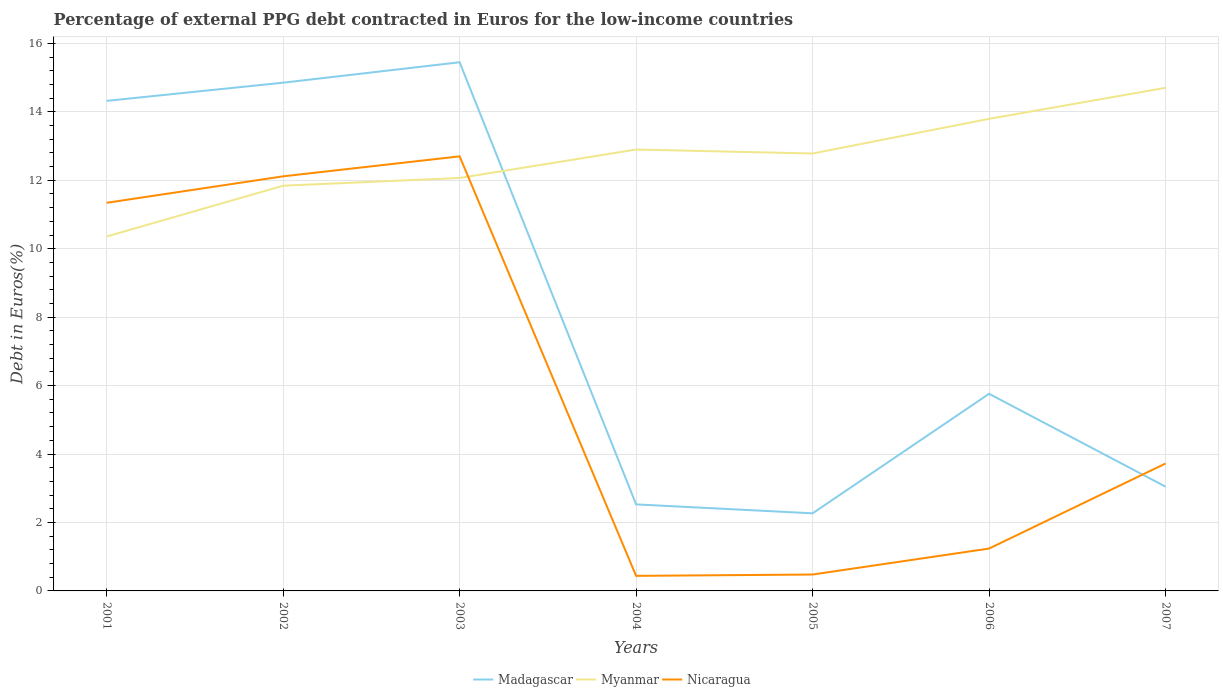Does the line corresponding to Madagascar intersect with the line corresponding to Nicaragua?
Offer a very short reply. Yes. Is the number of lines equal to the number of legend labels?
Your answer should be compact. Yes. Across all years, what is the maximum percentage of external PPG debt contracted in Euros in Myanmar?
Your response must be concise. 10.36. In which year was the percentage of external PPG debt contracted in Euros in Nicaragua maximum?
Your answer should be very brief. 2004. What is the total percentage of external PPG debt contracted in Euros in Nicaragua in the graph?
Keep it short and to the point. -2.49. What is the difference between the highest and the second highest percentage of external PPG debt contracted in Euros in Myanmar?
Ensure brevity in your answer.  4.35. What is the difference between two consecutive major ticks on the Y-axis?
Provide a short and direct response. 2. Are the values on the major ticks of Y-axis written in scientific E-notation?
Your response must be concise. No. Does the graph contain any zero values?
Your response must be concise. No. How many legend labels are there?
Offer a terse response. 3. How are the legend labels stacked?
Your response must be concise. Horizontal. What is the title of the graph?
Give a very brief answer. Percentage of external PPG debt contracted in Euros for the low-income countries. What is the label or title of the Y-axis?
Offer a very short reply. Debt in Euros(%). What is the Debt in Euros(%) in Madagascar in 2001?
Ensure brevity in your answer.  14.32. What is the Debt in Euros(%) of Myanmar in 2001?
Your response must be concise. 10.36. What is the Debt in Euros(%) of Nicaragua in 2001?
Your answer should be compact. 11.34. What is the Debt in Euros(%) in Madagascar in 2002?
Your answer should be very brief. 14.85. What is the Debt in Euros(%) of Myanmar in 2002?
Keep it short and to the point. 11.84. What is the Debt in Euros(%) in Nicaragua in 2002?
Your response must be concise. 12.12. What is the Debt in Euros(%) of Madagascar in 2003?
Keep it short and to the point. 15.45. What is the Debt in Euros(%) of Myanmar in 2003?
Provide a short and direct response. 12.07. What is the Debt in Euros(%) in Nicaragua in 2003?
Provide a succinct answer. 12.7. What is the Debt in Euros(%) in Madagascar in 2004?
Provide a succinct answer. 2.53. What is the Debt in Euros(%) of Myanmar in 2004?
Your answer should be compact. 12.9. What is the Debt in Euros(%) in Nicaragua in 2004?
Provide a succinct answer. 0.44. What is the Debt in Euros(%) of Madagascar in 2005?
Your answer should be very brief. 2.27. What is the Debt in Euros(%) in Myanmar in 2005?
Provide a short and direct response. 12.78. What is the Debt in Euros(%) of Nicaragua in 2005?
Your answer should be compact. 0.48. What is the Debt in Euros(%) in Madagascar in 2006?
Provide a short and direct response. 5.76. What is the Debt in Euros(%) of Myanmar in 2006?
Make the answer very short. 13.8. What is the Debt in Euros(%) of Nicaragua in 2006?
Offer a terse response. 1.24. What is the Debt in Euros(%) in Madagascar in 2007?
Give a very brief answer. 3.05. What is the Debt in Euros(%) in Myanmar in 2007?
Make the answer very short. 14.7. What is the Debt in Euros(%) in Nicaragua in 2007?
Keep it short and to the point. 3.72. Across all years, what is the maximum Debt in Euros(%) of Madagascar?
Offer a terse response. 15.45. Across all years, what is the maximum Debt in Euros(%) in Myanmar?
Offer a very short reply. 14.7. Across all years, what is the maximum Debt in Euros(%) in Nicaragua?
Give a very brief answer. 12.7. Across all years, what is the minimum Debt in Euros(%) in Madagascar?
Ensure brevity in your answer.  2.27. Across all years, what is the minimum Debt in Euros(%) of Myanmar?
Ensure brevity in your answer.  10.36. Across all years, what is the minimum Debt in Euros(%) in Nicaragua?
Ensure brevity in your answer.  0.44. What is the total Debt in Euros(%) of Madagascar in the graph?
Your answer should be very brief. 58.23. What is the total Debt in Euros(%) in Myanmar in the graph?
Your answer should be very brief. 88.45. What is the total Debt in Euros(%) of Nicaragua in the graph?
Your response must be concise. 42.04. What is the difference between the Debt in Euros(%) in Madagascar in 2001 and that in 2002?
Give a very brief answer. -0.53. What is the difference between the Debt in Euros(%) in Myanmar in 2001 and that in 2002?
Make the answer very short. -1.48. What is the difference between the Debt in Euros(%) of Nicaragua in 2001 and that in 2002?
Provide a succinct answer. -0.77. What is the difference between the Debt in Euros(%) of Madagascar in 2001 and that in 2003?
Offer a terse response. -1.13. What is the difference between the Debt in Euros(%) of Myanmar in 2001 and that in 2003?
Make the answer very short. -1.71. What is the difference between the Debt in Euros(%) in Nicaragua in 2001 and that in 2003?
Your answer should be very brief. -1.36. What is the difference between the Debt in Euros(%) of Madagascar in 2001 and that in 2004?
Give a very brief answer. 11.79. What is the difference between the Debt in Euros(%) in Myanmar in 2001 and that in 2004?
Your response must be concise. -2.54. What is the difference between the Debt in Euros(%) in Nicaragua in 2001 and that in 2004?
Offer a terse response. 10.9. What is the difference between the Debt in Euros(%) in Madagascar in 2001 and that in 2005?
Offer a terse response. 12.05. What is the difference between the Debt in Euros(%) in Myanmar in 2001 and that in 2005?
Your response must be concise. -2.43. What is the difference between the Debt in Euros(%) of Nicaragua in 2001 and that in 2005?
Offer a very short reply. 10.86. What is the difference between the Debt in Euros(%) of Madagascar in 2001 and that in 2006?
Offer a terse response. 8.56. What is the difference between the Debt in Euros(%) of Myanmar in 2001 and that in 2006?
Ensure brevity in your answer.  -3.44. What is the difference between the Debt in Euros(%) in Nicaragua in 2001 and that in 2006?
Your answer should be very brief. 10.1. What is the difference between the Debt in Euros(%) of Madagascar in 2001 and that in 2007?
Your answer should be compact. 11.27. What is the difference between the Debt in Euros(%) of Myanmar in 2001 and that in 2007?
Ensure brevity in your answer.  -4.35. What is the difference between the Debt in Euros(%) in Nicaragua in 2001 and that in 2007?
Offer a very short reply. 7.62. What is the difference between the Debt in Euros(%) in Madagascar in 2002 and that in 2003?
Give a very brief answer. -0.6. What is the difference between the Debt in Euros(%) of Myanmar in 2002 and that in 2003?
Your answer should be very brief. -0.23. What is the difference between the Debt in Euros(%) in Nicaragua in 2002 and that in 2003?
Give a very brief answer. -0.58. What is the difference between the Debt in Euros(%) of Madagascar in 2002 and that in 2004?
Give a very brief answer. 12.32. What is the difference between the Debt in Euros(%) in Myanmar in 2002 and that in 2004?
Make the answer very short. -1.06. What is the difference between the Debt in Euros(%) in Nicaragua in 2002 and that in 2004?
Ensure brevity in your answer.  11.68. What is the difference between the Debt in Euros(%) in Madagascar in 2002 and that in 2005?
Your answer should be compact. 12.58. What is the difference between the Debt in Euros(%) of Myanmar in 2002 and that in 2005?
Provide a succinct answer. -0.94. What is the difference between the Debt in Euros(%) in Nicaragua in 2002 and that in 2005?
Offer a terse response. 11.64. What is the difference between the Debt in Euros(%) in Madagascar in 2002 and that in 2006?
Your answer should be very brief. 9.09. What is the difference between the Debt in Euros(%) of Myanmar in 2002 and that in 2006?
Ensure brevity in your answer.  -1.95. What is the difference between the Debt in Euros(%) in Nicaragua in 2002 and that in 2006?
Provide a short and direct response. 10.88. What is the difference between the Debt in Euros(%) in Madagascar in 2002 and that in 2007?
Offer a terse response. 11.81. What is the difference between the Debt in Euros(%) in Myanmar in 2002 and that in 2007?
Your response must be concise. -2.86. What is the difference between the Debt in Euros(%) of Nicaragua in 2002 and that in 2007?
Provide a short and direct response. 8.39. What is the difference between the Debt in Euros(%) of Madagascar in 2003 and that in 2004?
Your answer should be compact. 12.92. What is the difference between the Debt in Euros(%) in Myanmar in 2003 and that in 2004?
Make the answer very short. -0.83. What is the difference between the Debt in Euros(%) of Nicaragua in 2003 and that in 2004?
Your answer should be very brief. 12.26. What is the difference between the Debt in Euros(%) of Madagascar in 2003 and that in 2005?
Your response must be concise. 13.18. What is the difference between the Debt in Euros(%) of Myanmar in 2003 and that in 2005?
Your answer should be compact. -0.71. What is the difference between the Debt in Euros(%) of Nicaragua in 2003 and that in 2005?
Make the answer very short. 12.22. What is the difference between the Debt in Euros(%) in Madagascar in 2003 and that in 2006?
Offer a terse response. 9.69. What is the difference between the Debt in Euros(%) in Myanmar in 2003 and that in 2006?
Give a very brief answer. -1.73. What is the difference between the Debt in Euros(%) of Nicaragua in 2003 and that in 2006?
Offer a terse response. 11.46. What is the difference between the Debt in Euros(%) of Madagascar in 2003 and that in 2007?
Offer a very short reply. 12.4. What is the difference between the Debt in Euros(%) of Myanmar in 2003 and that in 2007?
Provide a succinct answer. -2.63. What is the difference between the Debt in Euros(%) of Nicaragua in 2003 and that in 2007?
Offer a terse response. 8.98. What is the difference between the Debt in Euros(%) in Madagascar in 2004 and that in 2005?
Ensure brevity in your answer.  0.26. What is the difference between the Debt in Euros(%) of Myanmar in 2004 and that in 2005?
Keep it short and to the point. 0.12. What is the difference between the Debt in Euros(%) of Nicaragua in 2004 and that in 2005?
Make the answer very short. -0.04. What is the difference between the Debt in Euros(%) in Madagascar in 2004 and that in 2006?
Provide a succinct answer. -3.23. What is the difference between the Debt in Euros(%) of Myanmar in 2004 and that in 2006?
Offer a very short reply. -0.9. What is the difference between the Debt in Euros(%) in Nicaragua in 2004 and that in 2006?
Your answer should be compact. -0.8. What is the difference between the Debt in Euros(%) in Madagascar in 2004 and that in 2007?
Offer a terse response. -0.52. What is the difference between the Debt in Euros(%) in Myanmar in 2004 and that in 2007?
Your answer should be very brief. -1.8. What is the difference between the Debt in Euros(%) of Nicaragua in 2004 and that in 2007?
Ensure brevity in your answer.  -3.28. What is the difference between the Debt in Euros(%) of Madagascar in 2005 and that in 2006?
Keep it short and to the point. -3.49. What is the difference between the Debt in Euros(%) of Myanmar in 2005 and that in 2006?
Make the answer very short. -1.01. What is the difference between the Debt in Euros(%) of Nicaragua in 2005 and that in 2006?
Make the answer very short. -0.76. What is the difference between the Debt in Euros(%) of Madagascar in 2005 and that in 2007?
Make the answer very short. -0.78. What is the difference between the Debt in Euros(%) in Myanmar in 2005 and that in 2007?
Your answer should be compact. -1.92. What is the difference between the Debt in Euros(%) of Nicaragua in 2005 and that in 2007?
Provide a succinct answer. -3.24. What is the difference between the Debt in Euros(%) of Madagascar in 2006 and that in 2007?
Provide a succinct answer. 2.71. What is the difference between the Debt in Euros(%) in Myanmar in 2006 and that in 2007?
Give a very brief answer. -0.91. What is the difference between the Debt in Euros(%) in Nicaragua in 2006 and that in 2007?
Offer a terse response. -2.49. What is the difference between the Debt in Euros(%) in Madagascar in 2001 and the Debt in Euros(%) in Myanmar in 2002?
Your answer should be compact. 2.48. What is the difference between the Debt in Euros(%) of Madagascar in 2001 and the Debt in Euros(%) of Nicaragua in 2002?
Keep it short and to the point. 2.21. What is the difference between the Debt in Euros(%) in Myanmar in 2001 and the Debt in Euros(%) in Nicaragua in 2002?
Provide a short and direct response. -1.76. What is the difference between the Debt in Euros(%) of Madagascar in 2001 and the Debt in Euros(%) of Myanmar in 2003?
Provide a short and direct response. 2.25. What is the difference between the Debt in Euros(%) in Madagascar in 2001 and the Debt in Euros(%) in Nicaragua in 2003?
Provide a short and direct response. 1.62. What is the difference between the Debt in Euros(%) in Myanmar in 2001 and the Debt in Euros(%) in Nicaragua in 2003?
Provide a succinct answer. -2.34. What is the difference between the Debt in Euros(%) of Madagascar in 2001 and the Debt in Euros(%) of Myanmar in 2004?
Offer a very short reply. 1.42. What is the difference between the Debt in Euros(%) in Madagascar in 2001 and the Debt in Euros(%) in Nicaragua in 2004?
Your answer should be compact. 13.88. What is the difference between the Debt in Euros(%) in Myanmar in 2001 and the Debt in Euros(%) in Nicaragua in 2004?
Ensure brevity in your answer.  9.92. What is the difference between the Debt in Euros(%) in Madagascar in 2001 and the Debt in Euros(%) in Myanmar in 2005?
Your response must be concise. 1.54. What is the difference between the Debt in Euros(%) in Madagascar in 2001 and the Debt in Euros(%) in Nicaragua in 2005?
Your answer should be very brief. 13.84. What is the difference between the Debt in Euros(%) in Myanmar in 2001 and the Debt in Euros(%) in Nicaragua in 2005?
Provide a succinct answer. 9.88. What is the difference between the Debt in Euros(%) in Madagascar in 2001 and the Debt in Euros(%) in Myanmar in 2006?
Your response must be concise. 0.53. What is the difference between the Debt in Euros(%) of Madagascar in 2001 and the Debt in Euros(%) of Nicaragua in 2006?
Provide a short and direct response. 13.08. What is the difference between the Debt in Euros(%) of Myanmar in 2001 and the Debt in Euros(%) of Nicaragua in 2006?
Ensure brevity in your answer.  9.12. What is the difference between the Debt in Euros(%) of Madagascar in 2001 and the Debt in Euros(%) of Myanmar in 2007?
Provide a succinct answer. -0.38. What is the difference between the Debt in Euros(%) of Madagascar in 2001 and the Debt in Euros(%) of Nicaragua in 2007?
Your answer should be compact. 10.6. What is the difference between the Debt in Euros(%) of Myanmar in 2001 and the Debt in Euros(%) of Nicaragua in 2007?
Make the answer very short. 6.63. What is the difference between the Debt in Euros(%) of Madagascar in 2002 and the Debt in Euros(%) of Myanmar in 2003?
Make the answer very short. 2.78. What is the difference between the Debt in Euros(%) of Madagascar in 2002 and the Debt in Euros(%) of Nicaragua in 2003?
Keep it short and to the point. 2.15. What is the difference between the Debt in Euros(%) of Myanmar in 2002 and the Debt in Euros(%) of Nicaragua in 2003?
Offer a very short reply. -0.86. What is the difference between the Debt in Euros(%) in Madagascar in 2002 and the Debt in Euros(%) in Myanmar in 2004?
Your answer should be very brief. 1.95. What is the difference between the Debt in Euros(%) in Madagascar in 2002 and the Debt in Euros(%) in Nicaragua in 2004?
Provide a short and direct response. 14.41. What is the difference between the Debt in Euros(%) of Myanmar in 2002 and the Debt in Euros(%) of Nicaragua in 2004?
Provide a succinct answer. 11.4. What is the difference between the Debt in Euros(%) of Madagascar in 2002 and the Debt in Euros(%) of Myanmar in 2005?
Provide a short and direct response. 2.07. What is the difference between the Debt in Euros(%) of Madagascar in 2002 and the Debt in Euros(%) of Nicaragua in 2005?
Offer a terse response. 14.37. What is the difference between the Debt in Euros(%) in Myanmar in 2002 and the Debt in Euros(%) in Nicaragua in 2005?
Your answer should be compact. 11.36. What is the difference between the Debt in Euros(%) of Madagascar in 2002 and the Debt in Euros(%) of Myanmar in 2006?
Make the answer very short. 1.06. What is the difference between the Debt in Euros(%) of Madagascar in 2002 and the Debt in Euros(%) of Nicaragua in 2006?
Ensure brevity in your answer.  13.61. What is the difference between the Debt in Euros(%) of Myanmar in 2002 and the Debt in Euros(%) of Nicaragua in 2006?
Offer a very short reply. 10.6. What is the difference between the Debt in Euros(%) of Madagascar in 2002 and the Debt in Euros(%) of Myanmar in 2007?
Offer a terse response. 0.15. What is the difference between the Debt in Euros(%) in Madagascar in 2002 and the Debt in Euros(%) in Nicaragua in 2007?
Keep it short and to the point. 11.13. What is the difference between the Debt in Euros(%) in Myanmar in 2002 and the Debt in Euros(%) in Nicaragua in 2007?
Make the answer very short. 8.12. What is the difference between the Debt in Euros(%) of Madagascar in 2003 and the Debt in Euros(%) of Myanmar in 2004?
Provide a short and direct response. 2.55. What is the difference between the Debt in Euros(%) of Madagascar in 2003 and the Debt in Euros(%) of Nicaragua in 2004?
Offer a very short reply. 15.01. What is the difference between the Debt in Euros(%) of Myanmar in 2003 and the Debt in Euros(%) of Nicaragua in 2004?
Provide a succinct answer. 11.63. What is the difference between the Debt in Euros(%) of Madagascar in 2003 and the Debt in Euros(%) of Myanmar in 2005?
Ensure brevity in your answer.  2.67. What is the difference between the Debt in Euros(%) in Madagascar in 2003 and the Debt in Euros(%) in Nicaragua in 2005?
Provide a succinct answer. 14.97. What is the difference between the Debt in Euros(%) of Myanmar in 2003 and the Debt in Euros(%) of Nicaragua in 2005?
Offer a terse response. 11.59. What is the difference between the Debt in Euros(%) of Madagascar in 2003 and the Debt in Euros(%) of Myanmar in 2006?
Your response must be concise. 1.65. What is the difference between the Debt in Euros(%) in Madagascar in 2003 and the Debt in Euros(%) in Nicaragua in 2006?
Provide a succinct answer. 14.21. What is the difference between the Debt in Euros(%) of Myanmar in 2003 and the Debt in Euros(%) of Nicaragua in 2006?
Provide a succinct answer. 10.83. What is the difference between the Debt in Euros(%) in Madagascar in 2003 and the Debt in Euros(%) in Myanmar in 2007?
Offer a terse response. 0.75. What is the difference between the Debt in Euros(%) in Madagascar in 2003 and the Debt in Euros(%) in Nicaragua in 2007?
Provide a succinct answer. 11.73. What is the difference between the Debt in Euros(%) in Myanmar in 2003 and the Debt in Euros(%) in Nicaragua in 2007?
Offer a very short reply. 8.34. What is the difference between the Debt in Euros(%) in Madagascar in 2004 and the Debt in Euros(%) in Myanmar in 2005?
Keep it short and to the point. -10.25. What is the difference between the Debt in Euros(%) of Madagascar in 2004 and the Debt in Euros(%) of Nicaragua in 2005?
Your answer should be compact. 2.05. What is the difference between the Debt in Euros(%) in Myanmar in 2004 and the Debt in Euros(%) in Nicaragua in 2005?
Provide a succinct answer. 12.42. What is the difference between the Debt in Euros(%) in Madagascar in 2004 and the Debt in Euros(%) in Myanmar in 2006?
Offer a very short reply. -11.27. What is the difference between the Debt in Euros(%) of Madagascar in 2004 and the Debt in Euros(%) of Nicaragua in 2006?
Give a very brief answer. 1.29. What is the difference between the Debt in Euros(%) in Myanmar in 2004 and the Debt in Euros(%) in Nicaragua in 2006?
Offer a terse response. 11.66. What is the difference between the Debt in Euros(%) of Madagascar in 2004 and the Debt in Euros(%) of Myanmar in 2007?
Give a very brief answer. -12.17. What is the difference between the Debt in Euros(%) in Madagascar in 2004 and the Debt in Euros(%) in Nicaragua in 2007?
Your answer should be very brief. -1.2. What is the difference between the Debt in Euros(%) in Myanmar in 2004 and the Debt in Euros(%) in Nicaragua in 2007?
Give a very brief answer. 9.18. What is the difference between the Debt in Euros(%) of Madagascar in 2005 and the Debt in Euros(%) of Myanmar in 2006?
Provide a succinct answer. -11.53. What is the difference between the Debt in Euros(%) of Madagascar in 2005 and the Debt in Euros(%) of Nicaragua in 2006?
Give a very brief answer. 1.03. What is the difference between the Debt in Euros(%) in Myanmar in 2005 and the Debt in Euros(%) in Nicaragua in 2006?
Offer a very short reply. 11.54. What is the difference between the Debt in Euros(%) of Madagascar in 2005 and the Debt in Euros(%) of Myanmar in 2007?
Keep it short and to the point. -12.43. What is the difference between the Debt in Euros(%) in Madagascar in 2005 and the Debt in Euros(%) in Nicaragua in 2007?
Ensure brevity in your answer.  -1.46. What is the difference between the Debt in Euros(%) of Myanmar in 2005 and the Debt in Euros(%) of Nicaragua in 2007?
Keep it short and to the point. 9.06. What is the difference between the Debt in Euros(%) of Madagascar in 2006 and the Debt in Euros(%) of Myanmar in 2007?
Your answer should be very brief. -8.94. What is the difference between the Debt in Euros(%) in Madagascar in 2006 and the Debt in Euros(%) in Nicaragua in 2007?
Make the answer very short. 2.04. What is the difference between the Debt in Euros(%) of Myanmar in 2006 and the Debt in Euros(%) of Nicaragua in 2007?
Your response must be concise. 10.07. What is the average Debt in Euros(%) of Madagascar per year?
Your response must be concise. 8.32. What is the average Debt in Euros(%) in Myanmar per year?
Give a very brief answer. 12.63. What is the average Debt in Euros(%) in Nicaragua per year?
Offer a terse response. 6.01. In the year 2001, what is the difference between the Debt in Euros(%) of Madagascar and Debt in Euros(%) of Myanmar?
Give a very brief answer. 3.96. In the year 2001, what is the difference between the Debt in Euros(%) of Madagascar and Debt in Euros(%) of Nicaragua?
Provide a succinct answer. 2.98. In the year 2001, what is the difference between the Debt in Euros(%) in Myanmar and Debt in Euros(%) in Nicaragua?
Make the answer very short. -0.99. In the year 2002, what is the difference between the Debt in Euros(%) in Madagascar and Debt in Euros(%) in Myanmar?
Provide a short and direct response. 3.01. In the year 2002, what is the difference between the Debt in Euros(%) in Madagascar and Debt in Euros(%) in Nicaragua?
Offer a terse response. 2.74. In the year 2002, what is the difference between the Debt in Euros(%) of Myanmar and Debt in Euros(%) of Nicaragua?
Give a very brief answer. -0.27. In the year 2003, what is the difference between the Debt in Euros(%) in Madagascar and Debt in Euros(%) in Myanmar?
Provide a succinct answer. 3.38. In the year 2003, what is the difference between the Debt in Euros(%) of Madagascar and Debt in Euros(%) of Nicaragua?
Your response must be concise. 2.75. In the year 2003, what is the difference between the Debt in Euros(%) in Myanmar and Debt in Euros(%) in Nicaragua?
Make the answer very short. -0.63. In the year 2004, what is the difference between the Debt in Euros(%) of Madagascar and Debt in Euros(%) of Myanmar?
Keep it short and to the point. -10.37. In the year 2004, what is the difference between the Debt in Euros(%) of Madagascar and Debt in Euros(%) of Nicaragua?
Give a very brief answer. 2.09. In the year 2004, what is the difference between the Debt in Euros(%) of Myanmar and Debt in Euros(%) of Nicaragua?
Provide a succinct answer. 12.46. In the year 2005, what is the difference between the Debt in Euros(%) in Madagascar and Debt in Euros(%) in Myanmar?
Provide a short and direct response. -10.51. In the year 2005, what is the difference between the Debt in Euros(%) of Madagascar and Debt in Euros(%) of Nicaragua?
Offer a very short reply. 1.79. In the year 2005, what is the difference between the Debt in Euros(%) of Myanmar and Debt in Euros(%) of Nicaragua?
Provide a short and direct response. 12.3. In the year 2006, what is the difference between the Debt in Euros(%) in Madagascar and Debt in Euros(%) in Myanmar?
Make the answer very short. -8.03. In the year 2006, what is the difference between the Debt in Euros(%) in Madagascar and Debt in Euros(%) in Nicaragua?
Your response must be concise. 4.52. In the year 2006, what is the difference between the Debt in Euros(%) of Myanmar and Debt in Euros(%) of Nicaragua?
Offer a very short reply. 12.56. In the year 2007, what is the difference between the Debt in Euros(%) of Madagascar and Debt in Euros(%) of Myanmar?
Provide a succinct answer. -11.66. In the year 2007, what is the difference between the Debt in Euros(%) of Madagascar and Debt in Euros(%) of Nicaragua?
Make the answer very short. -0.68. In the year 2007, what is the difference between the Debt in Euros(%) in Myanmar and Debt in Euros(%) in Nicaragua?
Give a very brief answer. 10.98. What is the ratio of the Debt in Euros(%) of Madagascar in 2001 to that in 2002?
Your answer should be compact. 0.96. What is the ratio of the Debt in Euros(%) of Myanmar in 2001 to that in 2002?
Provide a short and direct response. 0.87. What is the ratio of the Debt in Euros(%) in Nicaragua in 2001 to that in 2002?
Make the answer very short. 0.94. What is the ratio of the Debt in Euros(%) of Madagascar in 2001 to that in 2003?
Your answer should be very brief. 0.93. What is the ratio of the Debt in Euros(%) of Myanmar in 2001 to that in 2003?
Provide a succinct answer. 0.86. What is the ratio of the Debt in Euros(%) in Nicaragua in 2001 to that in 2003?
Your response must be concise. 0.89. What is the ratio of the Debt in Euros(%) in Madagascar in 2001 to that in 2004?
Offer a terse response. 5.66. What is the ratio of the Debt in Euros(%) in Myanmar in 2001 to that in 2004?
Your response must be concise. 0.8. What is the ratio of the Debt in Euros(%) of Nicaragua in 2001 to that in 2004?
Offer a very short reply. 25.77. What is the ratio of the Debt in Euros(%) in Madagascar in 2001 to that in 2005?
Provide a short and direct response. 6.31. What is the ratio of the Debt in Euros(%) in Myanmar in 2001 to that in 2005?
Provide a short and direct response. 0.81. What is the ratio of the Debt in Euros(%) of Nicaragua in 2001 to that in 2005?
Provide a succinct answer. 23.67. What is the ratio of the Debt in Euros(%) of Madagascar in 2001 to that in 2006?
Give a very brief answer. 2.49. What is the ratio of the Debt in Euros(%) in Myanmar in 2001 to that in 2006?
Keep it short and to the point. 0.75. What is the ratio of the Debt in Euros(%) of Nicaragua in 2001 to that in 2006?
Offer a very short reply. 9.16. What is the ratio of the Debt in Euros(%) in Madagascar in 2001 to that in 2007?
Keep it short and to the point. 4.7. What is the ratio of the Debt in Euros(%) in Myanmar in 2001 to that in 2007?
Your answer should be very brief. 0.7. What is the ratio of the Debt in Euros(%) in Nicaragua in 2001 to that in 2007?
Your answer should be very brief. 3.05. What is the ratio of the Debt in Euros(%) in Madagascar in 2002 to that in 2003?
Your answer should be very brief. 0.96. What is the ratio of the Debt in Euros(%) of Myanmar in 2002 to that in 2003?
Keep it short and to the point. 0.98. What is the ratio of the Debt in Euros(%) of Nicaragua in 2002 to that in 2003?
Your answer should be very brief. 0.95. What is the ratio of the Debt in Euros(%) in Madagascar in 2002 to that in 2004?
Ensure brevity in your answer.  5.87. What is the ratio of the Debt in Euros(%) in Myanmar in 2002 to that in 2004?
Your answer should be very brief. 0.92. What is the ratio of the Debt in Euros(%) in Nicaragua in 2002 to that in 2004?
Your answer should be very brief. 27.52. What is the ratio of the Debt in Euros(%) in Madagascar in 2002 to that in 2005?
Provide a succinct answer. 6.55. What is the ratio of the Debt in Euros(%) in Myanmar in 2002 to that in 2005?
Your response must be concise. 0.93. What is the ratio of the Debt in Euros(%) in Nicaragua in 2002 to that in 2005?
Keep it short and to the point. 25.29. What is the ratio of the Debt in Euros(%) in Madagascar in 2002 to that in 2006?
Offer a very short reply. 2.58. What is the ratio of the Debt in Euros(%) of Myanmar in 2002 to that in 2006?
Your response must be concise. 0.86. What is the ratio of the Debt in Euros(%) of Nicaragua in 2002 to that in 2006?
Offer a very short reply. 9.78. What is the ratio of the Debt in Euros(%) of Madagascar in 2002 to that in 2007?
Keep it short and to the point. 4.87. What is the ratio of the Debt in Euros(%) in Myanmar in 2002 to that in 2007?
Give a very brief answer. 0.81. What is the ratio of the Debt in Euros(%) of Nicaragua in 2002 to that in 2007?
Your answer should be very brief. 3.25. What is the ratio of the Debt in Euros(%) of Madagascar in 2003 to that in 2004?
Offer a terse response. 6.11. What is the ratio of the Debt in Euros(%) of Myanmar in 2003 to that in 2004?
Provide a short and direct response. 0.94. What is the ratio of the Debt in Euros(%) of Nicaragua in 2003 to that in 2004?
Your answer should be compact. 28.85. What is the ratio of the Debt in Euros(%) in Madagascar in 2003 to that in 2005?
Offer a very short reply. 6.81. What is the ratio of the Debt in Euros(%) of Myanmar in 2003 to that in 2005?
Offer a very short reply. 0.94. What is the ratio of the Debt in Euros(%) in Nicaragua in 2003 to that in 2005?
Keep it short and to the point. 26.51. What is the ratio of the Debt in Euros(%) in Madagascar in 2003 to that in 2006?
Provide a short and direct response. 2.68. What is the ratio of the Debt in Euros(%) in Myanmar in 2003 to that in 2006?
Your response must be concise. 0.87. What is the ratio of the Debt in Euros(%) in Nicaragua in 2003 to that in 2006?
Provide a short and direct response. 10.26. What is the ratio of the Debt in Euros(%) of Madagascar in 2003 to that in 2007?
Provide a short and direct response. 5.07. What is the ratio of the Debt in Euros(%) of Myanmar in 2003 to that in 2007?
Provide a short and direct response. 0.82. What is the ratio of the Debt in Euros(%) in Nicaragua in 2003 to that in 2007?
Make the answer very short. 3.41. What is the ratio of the Debt in Euros(%) in Madagascar in 2004 to that in 2005?
Ensure brevity in your answer.  1.11. What is the ratio of the Debt in Euros(%) in Myanmar in 2004 to that in 2005?
Ensure brevity in your answer.  1.01. What is the ratio of the Debt in Euros(%) of Nicaragua in 2004 to that in 2005?
Your response must be concise. 0.92. What is the ratio of the Debt in Euros(%) of Madagascar in 2004 to that in 2006?
Your response must be concise. 0.44. What is the ratio of the Debt in Euros(%) of Myanmar in 2004 to that in 2006?
Your answer should be compact. 0.94. What is the ratio of the Debt in Euros(%) of Nicaragua in 2004 to that in 2006?
Your response must be concise. 0.36. What is the ratio of the Debt in Euros(%) of Madagascar in 2004 to that in 2007?
Keep it short and to the point. 0.83. What is the ratio of the Debt in Euros(%) of Myanmar in 2004 to that in 2007?
Offer a terse response. 0.88. What is the ratio of the Debt in Euros(%) of Nicaragua in 2004 to that in 2007?
Offer a terse response. 0.12. What is the ratio of the Debt in Euros(%) of Madagascar in 2005 to that in 2006?
Give a very brief answer. 0.39. What is the ratio of the Debt in Euros(%) in Myanmar in 2005 to that in 2006?
Provide a short and direct response. 0.93. What is the ratio of the Debt in Euros(%) in Nicaragua in 2005 to that in 2006?
Provide a short and direct response. 0.39. What is the ratio of the Debt in Euros(%) in Madagascar in 2005 to that in 2007?
Provide a short and direct response. 0.74. What is the ratio of the Debt in Euros(%) in Myanmar in 2005 to that in 2007?
Offer a very short reply. 0.87. What is the ratio of the Debt in Euros(%) in Nicaragua in 2005 to that in 2007?
Provide a succinct answer. 0.13. What is the ratio of the Debt in Euros(%) in Madagascar in 2006 to that in 2007?
Give a very brief answer. 1.89. What is the ratio of the Debt in Euros(%) in Myanmar in 2006 to that in 2007?
Keep it short and to the point. 0.94. What is the ratio of the Debt in Euros(%) of Nicaragua in 2006 to that in 2007?
Your answer should be very brief. 0.33. What is the difference between the highest and the second highest Debt in Euros(%) of Madagascar?
Your answer should be very brief. 0.6. What is the difference between the highest and the second highest Debt in Euros(%) in Myanmar?
Ensure brevity in your answer.  0.91. What is the difference between the highest and the second highest Debt in Euros(%) in Nicaragua?
Your answer should be compact. 0.58. What is the difference between the highest and the lowest Debt in Euros(%) in Madagascar?
Your answer should be compact. 13.18. What is the difference between the highest and the lowest Debt in Euros(%) in Myanmar?
Offer a terse response. 4.35. What is the difference between the highest and the lowest Debt in Euros(%) of Nicaragua?
Your answer should be very brief. 12.26. 